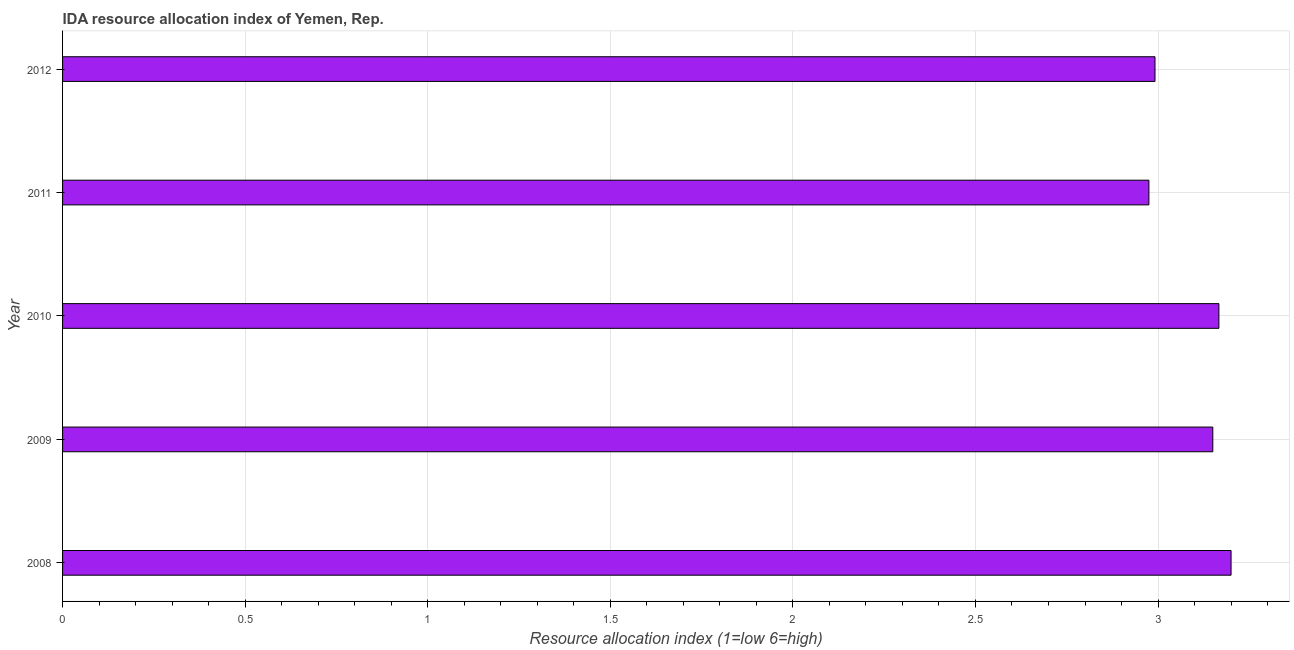What is the title of the graph?
Your response must be concise. IDA resource allocation index of Yemen, Rep. What is the label or title of the X-axis?
Offer a very short reply. Resource allocation index (1=low 6=high). What is the label or title of the Y-axis?
Your response must be concise. Year. Across all years, what is the minimum ida resource allocation index?
Make the answer very short. 2.98. In which year was the ida resource allocation index minimum?
Provide a succinct answer. 2011. What is the sum of the ida resource allocation index?
Your answer should be compact. 15.48. What is the difference between the ida resource allocation index in 2008 and 2010?
Offer a terse response. 0.03. What is the average ida resource allocation index per year?
Keep it short and to the point. 3.1. What is the median ida resource allocation index?
Give a very brief answer. 3.15. In how many years, is the ida resource allocation index greater than 2.3 ?
Offer a terse response. 5. Do a majority of the years between 2008 and 2009 (inclusive) have ida resource allocation index greater than 1.3 ?
Offer a terse response. Yes. What is the ratio of the ida resource allocation index in 2008 to that in 2012?
Offer a very short reply. 1.07. Is the ida resource allocation index in 2008 less than that in 2012?
Offer a terse response. No. What is the difference between the highest and the second highest ida resource allocation index?
Your answer should be very brief. 0.03. What is the difference between the highest and the lowest ida resource allocation index?
Your response must be concise. 0.23. In how many years, is the ida resource allocation index greater than the average ida resource allocation index taken over all years?
Provide a short and direct response. 3. How many years are there in the graph?
Provide a succinct answer. 5. What is the Resource allocation index (1=low 6=high) in 2009?
Your response must be concise. 3.15. What is the Resource allocation index (1=low 6=high) of 2010?
Provide a short and direct response. 3.17. What is the Resource allocation index (1=low 6=high) in 2011?
Offer a terse response. 2.98. What is the Resource allocation index (1=low 6=high) in 2012?
Provide a succinct answer. 2.99. What is the difference between the Resource allocation index (1=low 6=high) in 2008 and 2010?
Provide a succinct answer. 0.03. What is the difference between the Resource allocation index (1=low 6=high) in 2008 and 2011?
Provide a succinct answer. 0.23. What is the difference between the Resource allocation index (1=low 6=high) in 2008 and 2012?
Make the answer very short. 0.21. What is the difference between the Resource allocation index (1=low 6=high) in 2009 and 2010?
Provide a succinct answer. -0.02. What is the difference between the Resource allocation index (1=low 6=high) in 2009 and 2011?
Give a very brief answer. 0.17. What is the difference between the Resource allocation index (1=low 6=high) in 2009 and 2012?
Your answer should be very brief. 0.16. What is the difference between the Resource allocation index (1=low 6=high) in 2010 and 2011?
Ensure brevity in your answer.  0.19. What is the difference between the Resource allocation index (1=low 6=high) in 2010 and 2012?
Your response must be concise. 0.17. What is the difference between the Resource allocation index (1=low 6=high) in 2011 and 2012?
Keep it short and to the point. -0.02. What is the ratio of the Resource allocation index (1=low 6=high) in 2008 to that in 2010?
Keep it short and to the point. 1.01. What is the ratio of the Resource allocation index (1=low 6=high) in 2008 to that in 2011?
Your response must be concise. 1.08. What is the ratio of the Resource allocation index (1=low 6=high) in 2008 to that in 2012?
Offer a terse response. 1.07. What is the ratio of the Resource allocation index (1=low 6=high) in 2009 to that in 2010?
Your answer should be compact. 0.99. What is the ratio of the Resource allocation index (1=low 6=high) in 2009 to that in 2011?
Your answer should be very brief. 1.06. What is the ratio of the Resource allocation index (1=low 6=high) in 2009 to that in 2012?
Keep it short and to the point. 1.05. What is the ratio of the Resource allocation index (1=low 6=high) in 2010 to that in 2011?
Your answer should be very brief. 1.06. What is the ratio of the Resource allocation index (1=low 6=high) in 2010 to that in 2012?
Make the answer very short. 1.06. What is the ratio of the Resource allocation index (1=low 6=high) in 2011 to that in 2012?
Make the answer very short. 0.99. 